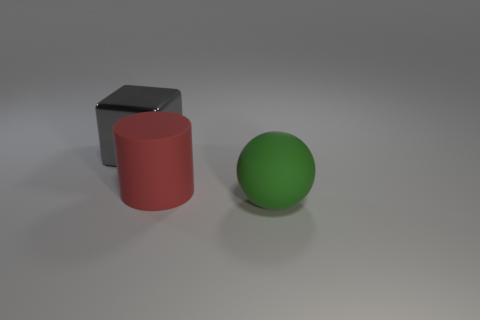Add 2 tiny green cylinders. How many objects exist? 5 Subtract all cylinders. How many objects are left? 2 Subtract 0 purple cylinders. How many objects are left? 3 Subtract all red matte cylinders. Subtract all red matte cylinders. How many objects are left? 1 Add 3 blocks. How many blocks are left? 4 Add 2 large cyan objects. How many large cyan objects exist? 2 